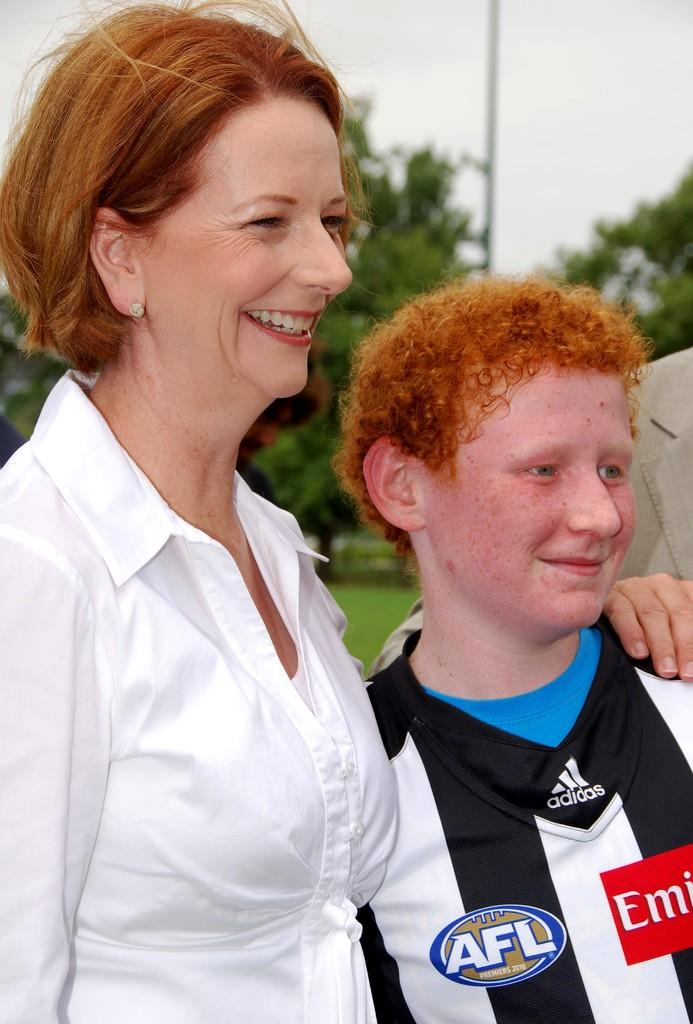<image>
Describe the image concisely. A woman standing next to a young man in a Adidas referee jersey. 